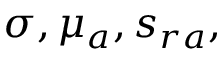<formula> <loc_0><loc_0><loc_500><loc_500>\sigma , \mu _ { a } , s _ { r a } ,</formula> 